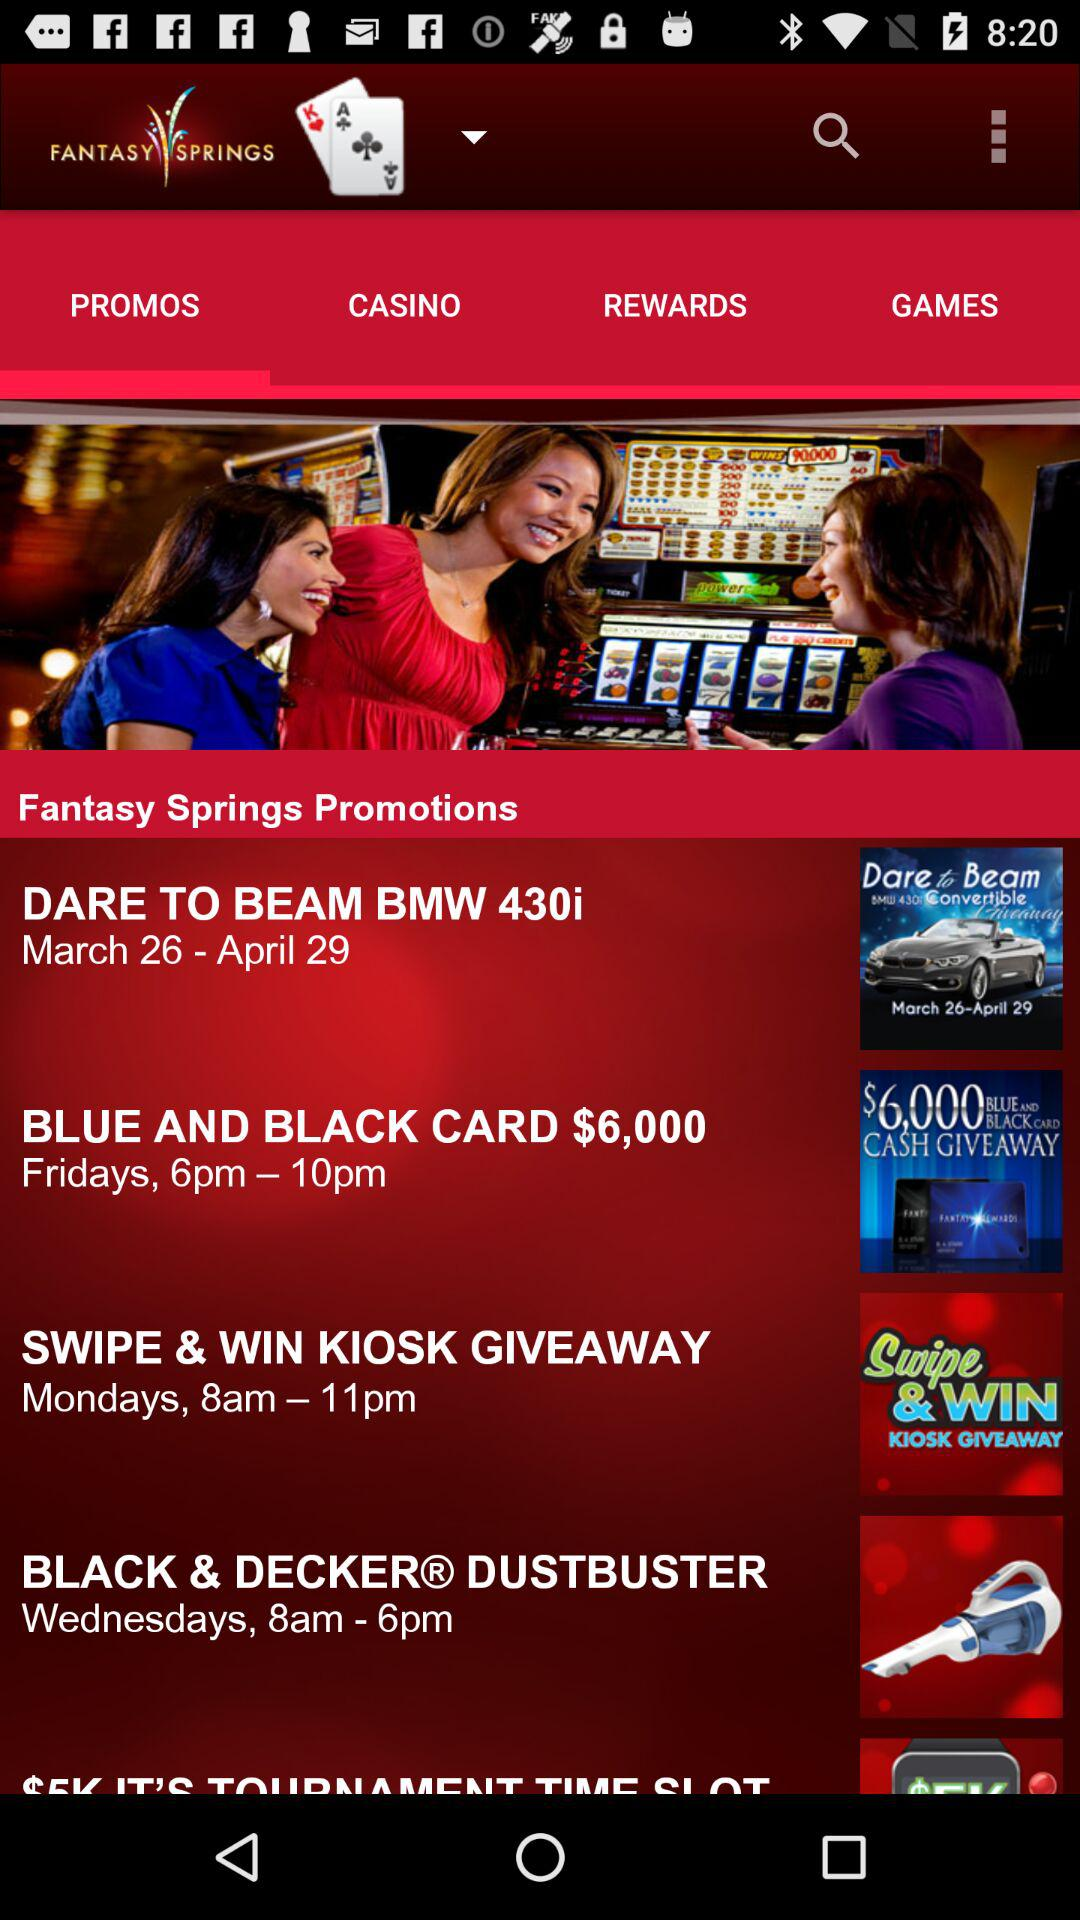How many promotions are there in total?
Answer the question using a single word or phrase. 5 